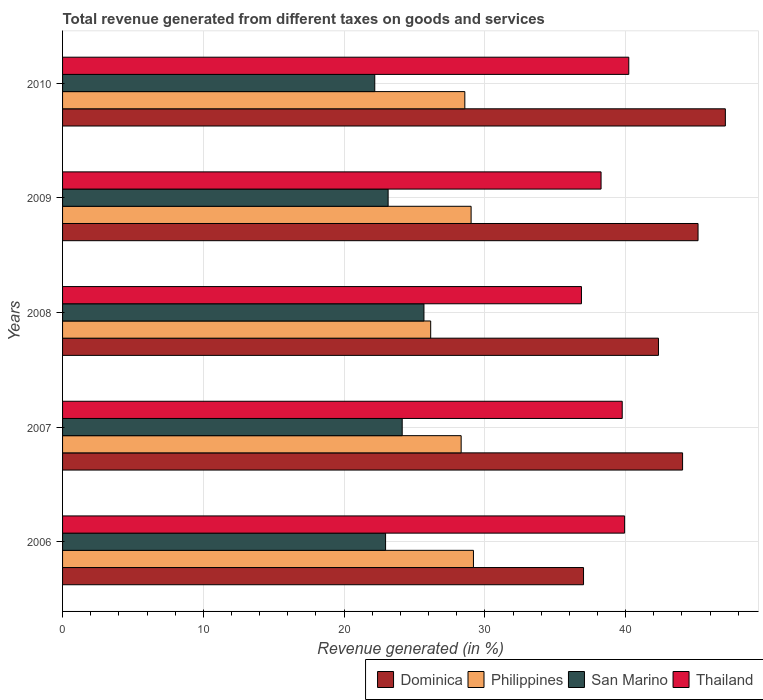How many groups of bars are there?
Offer a terse response. 5. What is the label of the 2nd group of bars from the top?
Provide a succinct answer. 2009. In how many cases, is the number of bars for a given year not equal to the number of legend labels?
Offer a very short reply. 0. What is the total revenue generated in Thailand in 2010?
Provide a succinct answer. 40.22. Across all years, what is the maximum total revenue generated in Thailand?
Your response must be concise. 40.22. Across all years, what is the minimum total revenue generated in Dominica?
Provide a succinct answer. 37.01. What is the total total revenue generated in Thailand in the graph?
Your answer should be compact. 195.02. What is the difference between the total revenue generated in Dominica in 2006 and that in 2009?
Ensure brevity in your answer.  -8.14. What is the difference between the total revenue generated in Thailand in 2010 and the total revenue generated in San Marino in 2009?
Your answer should be very brief. 17.1. What is the average total revenue generated in Thailand per year?
Provide a succinct answer. 39. In the year 2007, what is the difference between the total revenue generated in San Marino and total revenue generated in Dominica?
Offer a very short reply. -19.92. In how many years, is the total revenue generated in Philippines greater than 46 %?
Provide a short and direct response. 0. What is the ratio of the total revenue generated in Philippines in 2006 to that in 2010?
Your response must be concise. 1.02. What is the difference between the highest and the second highest total revenue generated in Thailand?
Keep it short and to the point. 0.3. What is the difference between the highest and the lowest total revenue generated in Dominica?
Offer a very short reply. 10.07. In how many years, is the total revenue generated in Philippines greater than the average total revenue generated in Philippines taken over all years?
Offer a terse response. 4. Is the sum of the total revenue generated in Dominica in 2006 and 2010 greater than the maximum total revenue generated in Thailand across all years?
Ensure brevity in your answer.  Yes. Is it the case that in every year, the sum of the total revenue generated in Philippines and total revenue generated in Thailand is greater than the sum of total revenue generated in San Marino and total revenue generated in Dominica?
Your answer should be compact. No. What does the 2nd bar from the top in 2010 represents?
Ensure brevity in your answer.  San Marino. What does the 1st bar from the bottom in 2010 represents?
Your answer should be very brief. Dominica. Is it the case that in every year, the sum of the total revenue generated in Thailand and total revenue generated in San Marino is greater than the total revenue generated in Dominica?
Make the answer very short. Yes. How many bars are there?
Provide a succinct answer. 20. What is the difference between two consecutive major ticks on the X-axis?
Ensure brevity in your answer.  10. Are the values on the major ticks of X-axis written in scientific E-notation?
Your answer should be compact. No. Does the graph contain any zero values?
Your response must be concise. No. Does the graph contain grids?
Your answer should be very brief. Yes. How many legend labels are there?
Make the answer very short. 4. How are the legend labels stacked?
Offer a terse response. Horizontal. What is the title of the graph?
Offer a terse response. Total revenue generated from different taxes on goods and services. What is the label or title of the X-axis?
Ensure brevity in your answer.  Revenue generated (in %). What is the label or title of the Y-axis?
Provide a short and direct response. Years. What is the Revenue generated (in %) in Dominica in 2006?
Offer a terse response. 37.01. What is the Revenue generated (in %) of Philippines in 2006?
Provide a succinct answer. 29.19. What is the Revenue generated (in %) of San Marino in 2006?
Ensure brevity in your answer.  22.95. What is the Revenue generated (in %) of Thailand in 2006?
Provide a succinct answer. 39.93. What is the Revenue generated (in %) in Dominica in 2007?
Ensure brevity in your answer.  44.04. What is the Revenue generated (in %) in Philippines in 2007?
Ensure brevity in your answer.  28.31. What is the Revenue generated (in %) in San Marino in 2007?
Ensure brevity in your answer.  24.13. What is the Revenue generated (in %) in Thailand in 2007?
Offer a terse response. 39.76. What is the Revenue generated (in %) in Dominica in 2008?
Your answer should be very brief. 42.33. What is the Revenue generated (in %) of Philippines in 2008?
Ensure brevity in your answer.  26.15. What is the Revenue generated (in %) in San Marino in 2008?
Make the answer very short. 25.67. What is the Revenue generated (in %) of Thailand in 2008?
Your answer should be very brief. 36.86. What is the Revenue generated (in %) of Dominica in 2009?
Your response must be concise. 45.14. What is the Revenue generated (in %) in Philippines in 2009?
Make the answer very short. 29.02. What is the Revenue generated (in %) of San Marino in 2009?
Offer a very short reply. 23.13. What is the Revenue generated (in %) of Thailand in 2009?
Your answer should be very brief. 38.25. What is the Revenue generated (in %) in Dominica in 2010?
Your response must be concise. 47.08. What is the Revenue generated (in %) of Philippines in 2010?
Offer a terse response. 28.58. What is the Revenue generated (in %) in San Marino in 2010?
Your response must be concise. 22.18. What is the Revenue generated (in %) in Thailand in 2010?
Provide a short and direct response. 40.22. Across all years, what is the maximum Revenue generated (in %) of Dominica?
Offer a very short reply. 47.08. Across all years, what is the maximum Revenue generated (in %) in Philippines?
Offer a very short reply. 29.19. Across all years, what is the maximum Revenue generated (in %) of San Marino?
Give a very brief answer. 25.67. Across all years, what is the maximum Revenue generated (in %) in Thailand?
Your response must be concise. 40.22. Across all years, what is the minimum Revenue generated (in %) in Dominica?
Provide a succinct answer. 37.01. Across all years, what is the minimum Revenue generated (in %) of Philippines?
Make the answer very short. 26.15. Across all years, what is the minimum Revenue generated (in %) of San Marino?
Give a very brief answer. 22.18. Across all years, what is the minimum Revenue generated (in %) of Thailand?
Your answer should be very brief. 36.86. What is the total Revenue generated (in %) of Dominica in the graph?
Your response must be concise. 215.61. What is the total Revenue generated (in %) of Philippines in the graph?
Ensure brevity in your answer.  141.25. What is the total Revenue generated (in %) in San Marino in the graph?
Your answer should be compact. 118.05. What is the total Revenue generated (in %) in Thailand in the graph?
Ensure brevity in your answer.  195.02. What is the difference between the Revenue generated (in %) of Dominica in 2006 and that in 2007?
Provide a short and direct response. -7.04. What is the difference between the Revenue generated (in %) in Philippines in 2006 and that in 2007?
Ensure brevity in your answer.  0.87. What is the difference between the Revenue generated (in %) in San Marino in 2006 and that in 2007?
Ensure brevity in your answer.  -1.18. What is the difference between the Revenue generated (in %) in Thailand in 2006 and that in 2007?
Ensure brevity in your answer.  0.17. What is the difference between the Revenue generated (in %) of Dominica in 2006 and that in 2008?
Keep it short and to the point. -5.32. What is the difference between the Revenue generated (in %) in Philippines in 2006 and that in 2008?
Keep it short and to the point. 3.04. What is the difference between the Revenue generated (in %) of San Marino in 2006 and that in 2008?
Ensure brevity in your answer.  -2.73. What is the difference between the Revenue generated (in %) of Thailand in 2006 and that in 2008?
Keep it short and to the point. 3.07. What is the difference between the Revenue generated (in %) in Dominica in 2006 and that in 2009?
Give a very brief answer. -8.14. What is the difference between the Revenue generated (in %) of Philippines in 2006 and that in 2009?
Provide a succinct answer. 0.17. What is the difference between the Revenue generated (in %) of San Marino in 2006 and that in 2009?
Your answer should be compact. -0.18. What is the difference between the Revenue generated (in %) of Thailand in 2006 and that in 2009?
Keep it short and to the point. 1.67. What is the difference between the Revenue generated (in %) of Dominica in 2006 and that in 2010?
Give a very brief answer. -10.07. What is the difference between the Revenue generated (in %) of Philippines in 2006 and that in 2010?
Make the answer very short. 0.61. What is the difference between the Revenue generated (in %) in San Marino in 2006 and that in 2010?
Your answer should be compact. 0.77. What is the difference between the Revenue generated (in %) of Thailand in 2006 and that in 2010?
Ensure brevity in your answer.  -0.3. What is the difference between the Revenue generated (in %) of Dominica in 2007 and that in 2008?
Make the answer very short. 1.71. What is the difference between the Revenue generated (in %) in Philippines in 2007 and that in 2008?
Offer a terse response. 2.16. What is the difference between the Revenue generated (in %) in San Marino in 2007 and that in 2008?
Your response must be concise. -1.55. What is the difference between the Revenue generated (in %) of Thailand in 2007 and that in 2008?
Provide a succinct answer. 2.9. What is the difference between the Revenue generated (in %) of Dominica in 2007 and that in 2009?
Offer a terse response. -1.1. What is the difference between the Revenue generated (in %) of Philippines in 2007 and that in 2009?
Make the answer very short. -0.71. What is the difference between the Revenue generated (in %) in San Marino in 2007 and that in 2009?
Ensure brevity in your answer.  1. What is the difference between the Revenue generated (in %) of Thailand in 2007 and that in 2009?
Make the answer very short. 1.5. What is the difference between the Revenue generated (in %) in Dominica in 2007 and that in 2010?
Your answer should be very brief. -3.04. What is the difference between the Revenue generated (in %) in Philippines in 2007 and that in 2010?
Your response must be concise. -0.26. What is the difference between the Revenue generated (in %) of San Marino in 2007 and that in 2010?
Your answer should be very brief. 1.95. What is the difference between the Revenue generated (in %) in Thailand in 2007 and that in 2010?
Your response must be concise. -0.47. What is the difference between the Revenue generated (in %) of Dominica in 2008 and that in 2009?
Provide a succinct answer. -2.81. What is the difference between the Revenue generated (in %) in Philippines in 2008 and that in 2009?
Offer a terse response. -2.87. What is the difference between the Revenue generated (in %) in San Marino in 2008 and that in 2009?
Give a very brief answer. 2.55. What is the difference between the Revenue generated (in %) in Thailand in 2008 and that in 2009?
Your answer should be compact. -1.39. What is the difference between the Revenue generated (in %) of Dominica in 2008 and that in 2010?
Offer a very short reply. -4.75. What is the difference between the Revenue generated (in %) of Philippines in 2008 and that in 2010?
Provide a short and direct response. -2.42. What is the difference between the Revenue generated (in %) in San Marino in 2008 and that in 2010?
Your response must be concise. 3.49. What is the difference between the Revenue generated (in %) of Thailand in 2008 and that in 2010?
Your answer should be very brief. -3.36. What is the difference between the Revenue generated (in %) in Dominica in 2009 and that in 2010?
Make the answer very short. -1.94. What is the difference between the Revenue generated (in %) in Philippines in 2009 and that in 2010?
Provide a succinct answer. 0.45. What is the difference between the Revenue generated (in %) of San Marino in 2009 and that in 2010?
Keep it short and to the point. 0.95. What is the difference between the Revenue generated (in %) in Thailand in 2009 and that in 2010?
Your answer should be very brief. -1.97. What is the difference between the Revenue generated (in %) of Dominica in 2006 and the Revenue generated (in %) of Philippines in 2007?
Your response must be concise. 8.69. What is the difference between the Revenue generated (in %) in Dominica in 2006 and the Revenue generated (in %) in San Marino in 2007?
Your answer should be compact. 12.88. What is the difference between the Revenue generated (in %) of Dominica in 2006 and the Revenue generated (in %) of Thailand in 2007?
Offer a very short reply. -2.75. What is the difference between the Revenue generated (in %) of Philippines in 2006 and the Revenue generated (in %) of San Marino in 2007?
Make the answer very short. 5.06. What is the difference between the Revenue generated (in %) of Philippines in 2006 and the Revenue generated (in %) of Thailand in 2007?
Offer a terse response. -10.57. What is the difference between the Revenue generated (in %) in San Marino in 2006 and the Revenue generated (in %) in Thailand in 2007?
Your response must be concise. -16.81. What is the difference between the Revenue generated (in %) of Dominica in 2006 and the Revenue generated (in %) of Philippines in 2008?
Your answer should be compact. 10.86. What is the difference between the Revenue generated (in %) in Dominica in 2006 and the Revenue generated (in %) in San Marino in 2008?
Make the answer very short. 11.34. What is the difference between the Revenue generated (in %) in Dominica in 2006 and the Revenue generated (in %) in Thailand in 2008?
Offer a very short reply. 0.15. What is the difference between the Revenue generated (in %) in Philippines in 2006 and the Revenue generated (in %) in San Marino in 2008?
Make the answer very short. 3.52. What is the difference between the Revenue generated (in %) of Philippines in 2006 and the Revenue generated (in %) of Thailand in 2008?
Offer a terse response. -7.67. What is the difference between the Revenue generated (in %) of San Marino in 2006 and the Revenue generated (in %) of Thailand in 2008?
Keep it short and to the point. -13.91. What is the difference between the Revenue generated (in %) in Dominica in 2006 and the Revenue generated (in %) in Philippines in 2009?
Ensure brevity in your answer.  7.99. What is the difference between the Revenue generated (in %) of Dominica in 2006 and the Revenue generated (in %) of San Marino in 2009?
Give a very brief answer. 13.88. What is the difference between the Revenue generated (in %) in Dominica in 2006 and the Revenue generated (in %) in Thailand in 2009?
Provide a short and direct response. -1.25. What is the difference between the Revenue generated (in %) in Philippines in 2006 and the Revenue generated (in %) in San Marino in 2009?
Your answer should be very brief. 6.06. What is the difference between the Revenue generated (in %) in Philippines in 2006 and the Revenue generated (in %) in Thailand in 2009?
Offer a very short reply. -9.07. What is the difference between the Revenue generated (in %) of San Marino in 2006 and the Revenue generated (in %) of Thailand in 2009?
Offer a very short reply. -15.31. What is the difference between the Revenue generated (in %) of Dominica in 2006 and the Revenue generated (in %) of Philippines in 2010?
Your answer should be compact. 8.43. What is the difference between the Revenue generated (in %) in Dominica in 2006 and the Revenue generated (in %) in San Marino in 2010?
Offer a very short reply. 14.83. What is the difference between the Revenue generated (in %) in Dominica in 2006 and the Revenue generated (in %) in Thailand in 2010?
Offer a very short reply. -3.21. What is the difference between the Revenue generated (in %) in Philippines in 2006 and the Revenue generated (in %) in San Marino in 2010?
Your answer should be very brief. 7.01. What is the difference between the Revenue generated (in %) of Philippines in 2006 and the Revenue generated (in %) of Thailand in 2010?
Offer a very short reply. -11.03. What is the difference between the Revenue generated (in %) in San Marino in 2006 and the Revenue generated (in %) in Thailand in 2010?
Provide a short and direct response. -17.28. What is the difference between the Revenue generated (in %) of Dominica in 2007 and the Revenue generated (in %) of Philippines in 2008?
Ensure brevity in your answer.  17.89. What is the difference between the Revenue generated (in %) in Dominica in 2007 and the Revenue generated (in %) in San Marino in 2008?
Your answer should be very brief. 18.37. What is the difference between the Revenue generated (in %) in Dominica in 2007 and the Revenue generated (in %) in Thailand in 2008?
Ensure brevity in your answer.  7.18. What is the difference between the Revenue generated (in %) in Philippines in 2007 and the Revenue generated (in %) in San Marino in 2008?
Your response must be concise. 2.64. What is the difference between the Revenue generated (in %) of Philippines in 2007 and the Revenue generated (in %) of Thailand in 2008?
Your answer should be compact. -8.55. What is the difference between the Revenue generated (in %) of San Marino in 2007 and the Revenue generated (in %) of Thailand in 2008?
Make the answer very short. -12.73. What is the difference between the Revenue generated (in %) in Dominica in 2007 and the Revenue generated (in %) in Philippines in 2009?
Your response must be concise. 15.02. What is the difference between the Revenue generated (in %) of Dominica in 2007 and the Revenue generated (in %) of San Marino in 2009?
Provide a short and direct response. 20.92. What is the difference between the Revenue generated (in %) of Dominica in 2007 and the Revenue generated (in %) of Thailand in 2009?
Provide a short and direct response. 5.79. What is the difference between the Revenue generated (in %) in Philippines in 2007 and the Revenue generated (in %) in San Marino in 2009?
Ensure brevity in your answer.  5.19. What is the difference between the Revenue generated (in %) of Philippines in 2007 and the Revenue generated (in %) of Thailand in 2009?
Make the answer very short. -9.94. What is the difference between the Revenue generated (in %) in San Marino in 2007 and the Revenue generated (in %) in Thailand in 2009?
Provide a short and direct response. -14.13. What is the difference between the Revenue generated (in %) of Dominica in 2007 and the Revenue generated (in %) of Philippines in 2010?
Make the answer very short. 15.47. What is the difference between the Revenue generated (in %) of Dominica in 2007 and the Revenue generated (in %) of San Marino in 2010?
Provide a succinct answer. 21.87. What is the difference between the Revenue generated (in %) of Dominica in 2007 and the Revenue generated (in %) of Thailand in 2010?
Provide a short and direct response. 3.82. What is the difference between the Revenue generated (in %) in Philippines in 2007 and the Revenue generated (in %) in San Marino in 2010?
Give a very brief answer. 6.14. What is the difference between the Revenue generated (in %) in Philippines in 2007 and the Revenue generated (in %) in Thailand in 2010?
Keep it short and to the point. -11.91. What is the difference between the Revenue generated (in %) in San Marino in 2007 and the Revenue generated (in %) in Thailand in 2010?
Make the answer very short. -16.1. What is the difference between the Revenue generated (in %) of Dominica in 2008 and the Revenue generated (in %) of Philippines in 2009?
Offer a very short reply. 13.31. What is the difference between the Revenue generated (in %) of Dominica in 2008 and the Revenue generated (in %) of San Marino in 2009?
Offer a terse response. 19.2. What is the difference between the Revenue generated (in %) of Dominica in 2008 and the Revenue generated (in %) of Thailand in 2009?
Make the answer very short. 4.08. What is the difference between the Revenue generated (in %) of Philippines in 2008 and the Revenue generated (in %) of San Marino in 2009?
Provide a short and direct response. 3.02. What is the difference between the Revenue generated (in %) in Philippines in 2008 and the Revenue generated (in %) in Thailand in 2009?
Keep it short and to the point. -12.1. What is the difference between the Revenue generated (in %) in San Marino in 2008 and the Revenue generated (in %) in Thailand in 2009?
Ensure brevity in your answer.  -12.58. What is the difference between the Revenue generated (in %) of Dominica in 2008 and the Revenue generated (in %) of Philippines in 2010?
Offer a very short reply. 13.76. What is the difference between the Revenue generated (in %) in Dominica in 2008 and the Revenue generated (in %) in San Marino in 2010?
Provide a short and direct response. 20.15. What is the difference between the Revenue generated (in %) of Dominica in 2008 and the Revenue generated (in %) of Thailand in 2010?
Your response must be concise. 2.11. What is the difference between the Revenue generated (in %) of Philippines in 2008 and the Revenue generated (in %) of San Marino in 2010?
Keep it short and to the point. 3.97. What is the difference between the Revenue generated (in %) of Philippines in 2008 and the Revenue generated (in %) of Thailand in 2010?
Provide a succinct answer. -14.07. What is the difference between the Revenue generated (in %) in San Marino in 2008 and the Revenue generated (in %) in Thailand in 2010?
Provide a short and direct response. -14.55. What is the difference between the Revenue generated (in %) of Dominica in 2009 and the Revenue generated (in %) of Philippines in 2010?
Offer a terse response. 16.57. What is the difference between the Revenue generated (in %) of Dominica in 2009 and the Revenue generated (in %) of San Marino in 2010?
Your response must be concise. 22.96. What is the difference between the Revenue generated (in %) of Dominica in 2009 and the Revenue generated (in %) of Thailand in 2010?
Provide a short and direct response. 4.92. What is the difference between the Revenue generated (in %) in Philippines in 2009 and the Revenue generated (in %) in San Marino in 2010?
Make the answer very short. 6.84. What is the difference between the Revenue generated (in %) of Philippines in 2009 and the Revenue generated (in %) of Thailand in 2010?
Your answer should be compact. -11.2. What is the difference between the Revenue generated (in %) in San Marino in 2009 and the Revenue generated (in %) in Thailand in 2010?
Provide a short and direct response. -17.1. What is the average Revenue generated (in %) in Dominica per year?
Your response must be concise. 43.12. What is the average Revenue generated (in %) in Philippines per year?
Provide a short and direct response. 28.25. What is the average Revenue generated (in %) in San Marino per year?
Keep it short and to the point. 23.61. What is the average Revenue generated (in %) of Thailand per year?
Your answer should be very brief. 39. In the year 2006, what is the difference between the Revenue generated (in %) in Dominica and Revenue generated (in %) in Philippines?
Your answer should be very brief. 7.82. In the year 2006, what is the difference between the Revenue generated (in %) in Dominica and Revenue generated (in %) in San Marino?
Ensure brevity in your answer.  14.06. In the year 2006, what is the difference between the Revenue generated (in %) in Dominica and Revenue generated (in %) in Thailand?
Give a very brief answer. -2.92. In the year 2006, what is the difference between the Revenue generated (in %) of Philippines and Revenue generated (in %) of San Marino?
Provide a short and direct response. 6.24. In the year 2006, what is the difference between the Revenue generated (in %) in Philippines and Revenue generated (in %) in Thailand?
Offer a terse response. -10.74. In the year 2006, what is the difference between the Revenue generated (in %) in San Marino and Revenue generated (in %) in Thailand?
Offer a terse response. -16.98. In the year 2007, what is the difference between the Revenue generated (in %) of Dominica and Revenue generated (in %) of Philippines?
Offer a terse response. 15.73. In the year 2007, what is the difference between the Revenue generated (in %) of Dominica and Revenue generated (in %) of San Marino?
Your answer should be very brief. 19.92. In the year 2007, what is the difference between the Revenue generated (in %) of Dominica and Revenue generated (in %) of Thailand?
Provide a short and direct response. 4.29. In the year 2007, what is the difference between the Revenue generated (in %) of Philippines and Revenue generated (in %) of San Marino?
Ensure brevity in your answer.  4.19. In the year 2007, what is the difference between the Revenue generated (in %) in Philippines and Revenue generated (in %) in Thailand?
Provide a short and direct response. -11.44. In the year 2007, what is the difference between the Revenue generated (in %) of San Marino and Revenue generated (in %) of Thailand?
Ensure brevity in your answer.  -15.63. In the year 2008, what is the difference between the Revenue generated (in %) in Dominica and Revenue generated (in %) in Philippines?
Make the answer very short. 16.18. In the year 2008, what is the difference between the Revenue generated (in %) in Dominica and Revenue generated (in %) in San Marino?
Make the answer very short. 16.66. In the year 2008, what is the difference between the Revenue generated (in %) in Dominica and Revenue generated (in %) in Thailand?
Ensure brevity in your answer.  5.47. In the year 2008, what is the difference between the Revenue generated (in %) of Philippines and Revenue generated (in %) of San Marino?
Your answer should be compact. 0.48. In the year 2008, what is the difference between the Revenue generated (in %) in Philippines and Revenue generated (in %) in Thailand?
Keep it short and to the point. -10.71. In the year 2008, what is the difference between the Revenue generated (in %) in San Marino and Revenue generated (in %) in Thailand?
Your response must be concise. -11.19. In the year 2009, what is the difference between the Revenue generated (in %) in Dominica and Revenue generated (in %) in Philippines?
Make the answer very short. 16.12. In the year 2009, what is the difference between the Revenue generated (in %) of Dominica and Revenue generated (in %) of San Marino?
Offer a terse response. 22.02. In the year 2009, what is the difference between the Revenue generated (in %) of Dominica and Revenue generated (in %) of Thailand?
Ensure brevity in your answer.  6.89. In the year 2009, what is the difference between the Revenue generated (in %) of Philippines and Revenue generated (in %) of San Marino?
Your answer should be very brief. 5.89. In the year 2009, what is the difference between the Revenue generated (in %) in Philippines and Revenue generated (in %) in Thailand?
Your answer should be very brief. -9.23. In the year 2009, what is the difference between the Revenue generated (in %) of San Marino and Revenue generated (in %) of Thailand?
Give a very brief answer. -15.13. In the year 2010, what is the difference between the Revenue generated (in %) of Dominica and Revenue generated (in %) of Philippines?
Ensure brevity in your answer.  18.51. In the year 2010, what is the difference between the Revenue generated (in %) in Dominica and Revenue generated (in %) in San Marino?
Your answer should be compact. 24.9. In the year 2010, what is the difference between the Revenue generated (in %) of Dominica and Revenue generated (in %) of Thailand?
Keep it short and to the point. 6.86. In the year 2010, what is the difference between the Revenue generated (in %) in Philippines and Revenue generated (in %) in San Marino?
Your answer should be compact. 6.4. In the year 2010, what is the difference between the Revenue generated (in %) of Philippines and Revenue generated (in %) of Thailand?
Ensure brevity in your answer.  -11.65. In the year 2010, what is the difference between the Revenue generated (in %) of San Marino and Revenue generated (in %) of Thailand?
Keep it short and to the point. -18.04. What is the ratio of the Revenue generated (in %) in Dominica in 2006 to that in 2007?
Your response must be concise. 0.84. What is the ratio of the Revenue generated (in %) of Philippines in 2006 to that in 2007?
Your response must be concise. 1.03. What is the ratio of the Revenue generated (in %) in San Marino in 2006 to that in 2007?
Your answer should be compact. 0.95. What is the ratio of the Revenue generated (in %) in Dominica in 2006 to that in 2008?
Provide a short and direct response. 0.87. What is the ratio of the Revenue generated (in %) in Philippines in 2006 to that in 2008?
Offer a terse response. 1.12. What is the ratio of the Revenue generated (in %) in San Marino in 2006 to that in 2008?
Provide a succinct answer. 0.89. What is the ratio of the Revenue generated (in %) of Thailand in 2006 to that in 2008?
Ensure brevity in your answer.  1.08. What is the ratio of the Revenue generated (in %) in Dominica in 2006 to that in 2009?
Your answer should be very brief. 0.82. What is the ratio of the Revenue generated (in %) in San Marino in 2006 to that in 2009?
Keep it short and to the point. 0.99. What is the ratio of the Revenue generated (in %) in Thailand in 2006 to that in 2009?
Give a very brief answer. 1.04. What is the ratio of the Revenue generated (in %) in Dominica in 2006 to that in 2010?
Offer a very short reply. 0.79. What is the ratio of the Revenue generated (in %) of Philippines in 2006 to that in 2010?
Provide a short and direct response. 1.02. What is the ratio of the Revenue generated (in %) in San Marino in 2006 to that in 2010?
Your response must be concise. 1.03. What is the ratio of the Revenue generated (in %) in Dominica in 2007 to that in 2008?
Provide a short and direct response. 1.04. What is the ratio of the Revenue generated (in %) in Philippines in 2007 to that in 2008?
Your response must be concise. 1.08. What is the ratio of the Revenue generated (in %) in San Marino in 2007 to that in 2008?
Make the answer very short. 0.94. What is the ratio of the Revenue generated (in %) of Thailand in 2007 to that in 2008?
Your answer should be very brief. 1.08. What is the ratio of the Revenue generated (in %) of Dominica in 2007 to that in 2009?
Provide a short and direct response. 0.98. What is the ratio of the Revenue generated (in %) in Philippines in 2007 to that in 2009?
Keep it short and to the point. 0.98. What is the ratio of the Revenue generated (in %) of San Marino in 2007 to that in 2009?
Provide a short and direct response. 1.04. What is the ratio of the Revenue generated (in %) in Thailand in 2007 to that in 2009?
Your answer should be very brief. 1.04. What is the ratio of the Revenue generated (in %) of Dominica in 2007 to that in 2010?
Your response must be concise. 0.94. What is the ratio of the Revenue generated (in %) in Philippines in 2007 to that in 2010?
Your answer should be compact. 0.99. What is the ratio of the Revenue generated (in %) of San Marino in 2007 to that in 2010?
Make the answer very short. 1.09. What is the ratio of the Revenue generated (in %) in Thailand in 2007 to that in 2010?
Make the answer very short. 0.99. What is the ratio of the Revenue generated (in %) of Dominica in 2008 to that in 2009?
Offer a terse response. 0.94. What is the ratio of the Revenue generated (in %) of Philippines in 2008 to that in 2009?
Offer a very short reply. 0.9. What is the ratio of the Revenue generated (in %) of San Marino in 2008 to that in 2009?
Your answer should be very brief. 1.11. What is the ratio of the Revenue generated (in %) of Thailand in 2008 to that in 2009?
Your answer should be compact. 0.96. What is the ratio of the Revenue generated (in %) of Dominica in 2008 to that in 2010?
Offer a terse response. 0.9. What is the ratio of the Revenue generated (in %) of Philippines in 2008 to that in 2010?
Offer a terse response. 0.92. What is the ratio of the Revenue generated (in %) in San Marino in 2008 to that in 2010?
Keep it short and to the point. 1.16. What is the ratio of the Revenue generated (in %) of Thailand in 2008 to that in 2010?
Offer a very short reply. 0.92. What is the ratio of the Revenue generated (in %) of Dominica in 2009 to that in 2010?
Provide a succinct answer. 0.96. What is the ratio of the Revenue generated (in %) of Philippines in 2009 to that in 2010?
Keep it short and to the point. 1.02. What is the ratio of the Revenue generated (in %) of San Marino in 2009 to that in 2010?
Make the answer very short. 1.04. What is the ratio of the Revenue generated (in %) in Thailand in 2009 to that in 2010?
Ensure brevity in your answer.  0.95. What is the difference between the highest and the second highest Revenue generated (in %) in Dominica?
Offer a very short reply. 1.94. What is the difference between the highest and the second highest Revenue generated (in %) of Philippines?
Your answer should be compact. 0.17. What is the difference between the highest and the second highest Revenue generated (in %) in San Marino?
Ensure brevity in your answer.  1.55. What is the difference between the highest and the second highest Revenue generated (in %) in Thailand?
Offer a very short reply. 0.3. What is the difference between the highest and the lowest Revenue generated (in %) of Dominica?
Make the answer very short. 10.07. What is the difference between the highest and the lowest Revenue generated (in %) in Philippines?
Make the answer very short. 3.04. What is the difference between the highest and the lowest Revenue generated (in %) of San Marino?
Your answer should be compact. 3.49. What is the difference between the highest and the lowest Revenue generated (in %) in Thailand?
Make the answer very short. 3.36. 